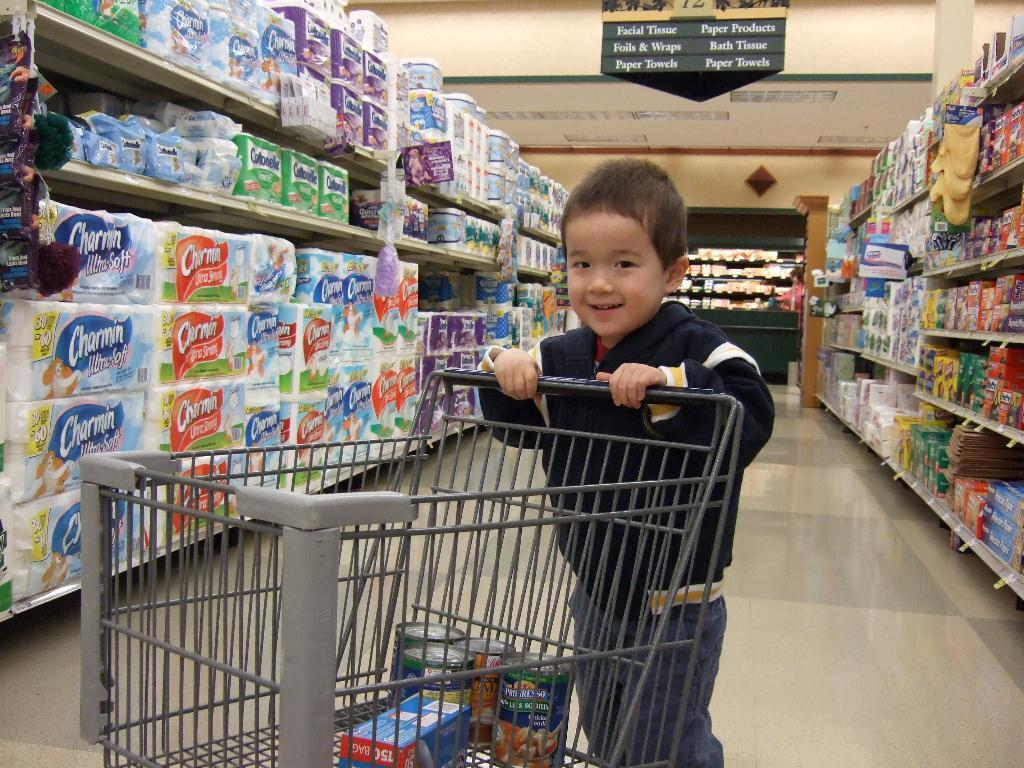<image>
Share a concise interpretation of the image provided. A grocery aisle with a kid and Charmin toilet paper on the shelf 